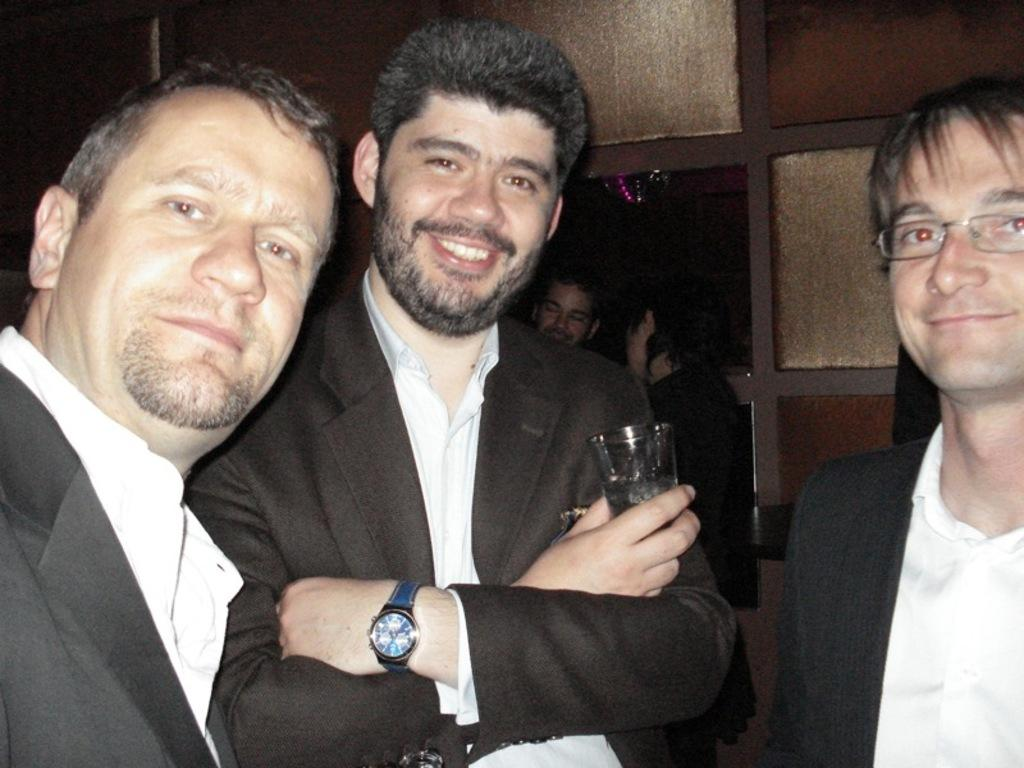How many people are in the image? There is a group of persons in the image. What are the people in the image doing? The persons are standing on the floor. Can you describe the clothing of one of the persons? One person is wearing a coat. What is the person wearing a coat holding in his hand? The person wearing a coat is holding a glass in his hand. Can you identify any accessories worn by the people in the image? One person is wearing spectacles. What type of note can be seen hanging from the person's fang in the image? There is no person with a fang present in the image, and therefore no such note can be observed. 